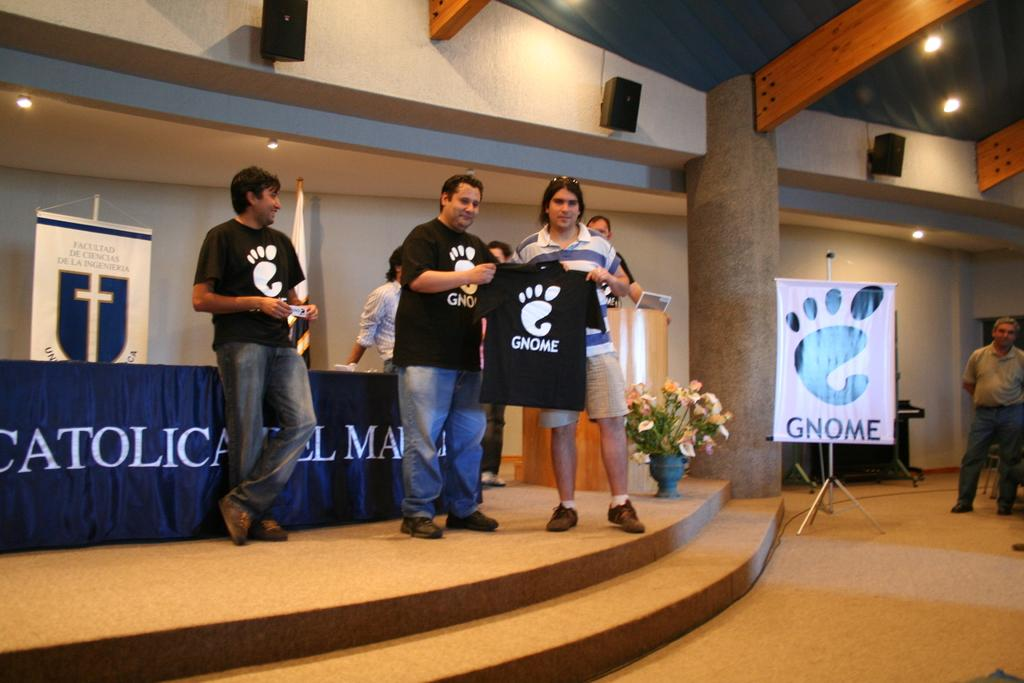Provide a one-sentence caption for the provided image. A group of people stand on the stage of a church wearing black Gnome t-shirts. 